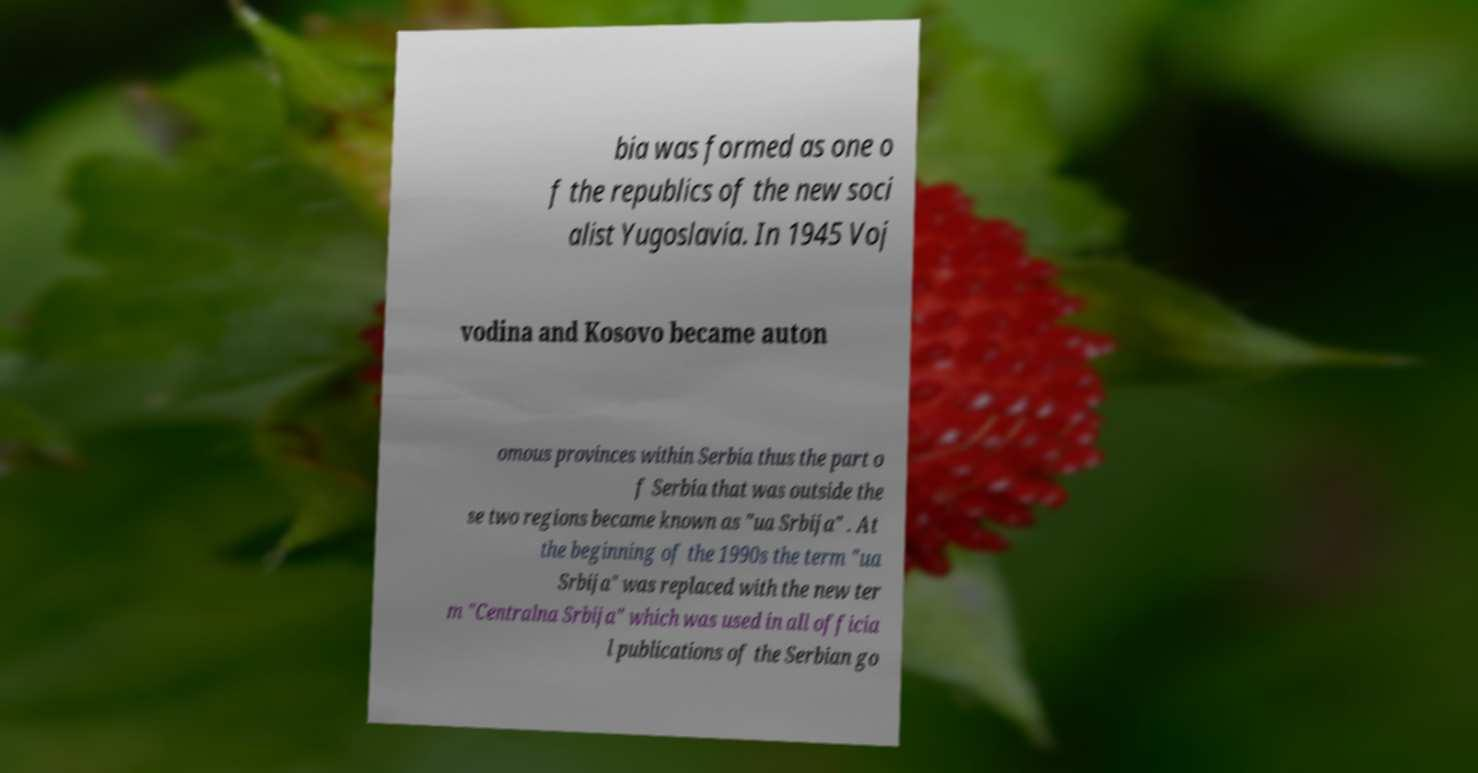Could you extract and type out the text from this image? bia was formed as one o f the republics of the new soci alist Yugoslavia. In 1945 Voj vodina and Kosovo became auton omous provinces within Serbia thus the part o f Serbia that was outside the se two regions became known as "ua Srbija" . At the beginning of the 1990s the term "ua Srbija" was replaced with the new ter m "Centralna Srbija" which was used in all officia l publications of the Serbian go 